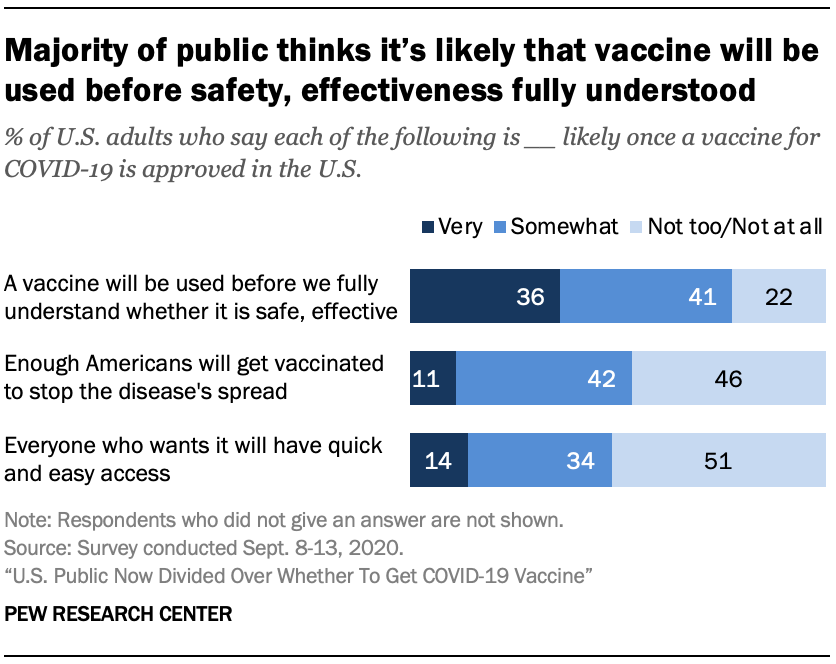Specify some key components in this picture. The use of three different shades of blue to represent the graph is noted. The product of the median and the smallest value of the navy blue bar is 154. 